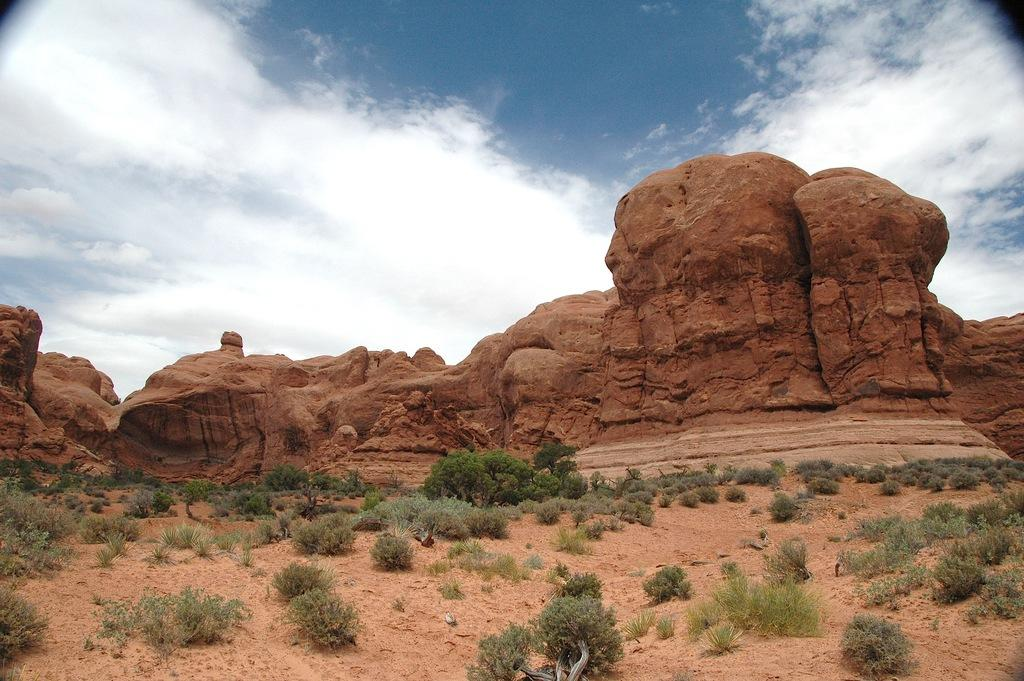What type of landform is present in the image? There is a hill in the image. What type of vegetation can be seen on the hill? There are bushes in the image. What is visible at the top of the image? The sky is visible at the top of the image. Can you tell me how many times the aunt has bitten into the hill in the image? There is no aunt or biting action present in the image; it features a hill with bushes and a visible sky. 